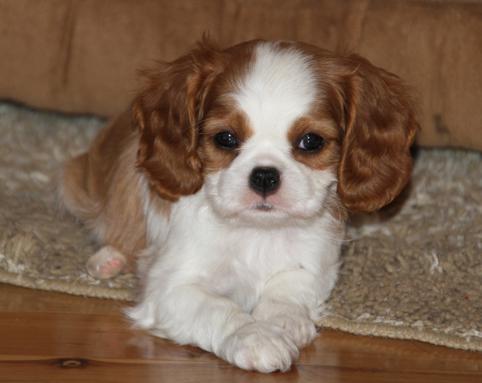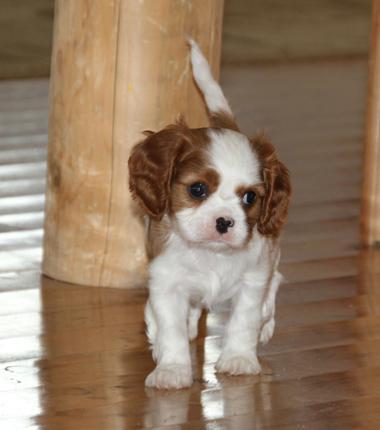The first image is the image on the left, the second image is the image on the right. For the images displayed, is the sentence "Two dogs on grassy ground are visible in the left image." factually correct? Answer yes or no. No. The first image is the image on the left, the second image is the image on the right. For the images shown, is this caption "The dog on the right is standing in the green grass outside." true? Answer yes or no. No. The first image is the image on the left, the second image is the image on the right. For the images shown, is this caption "The dog on the right is standing in the grass." true? Answer yes or no. No. The first image is the image on the left, the second image is the image on the right. Examine the images to the left and right. Is the description "All the dogs are lying down and one dog has its head facing towards the left side of the image." accurate? Answer yes or no. No. The first image is the image on the left, the second image is the image on the right. Analyze the images presented: Is the assertion "Left and right images feature one dog on the same type of surface as in the other image." valid? Answer yes or no. Yes. 